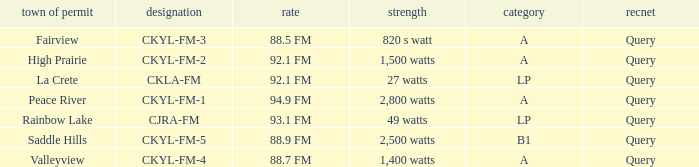9 fm frequency? CKYL-FM-1. 